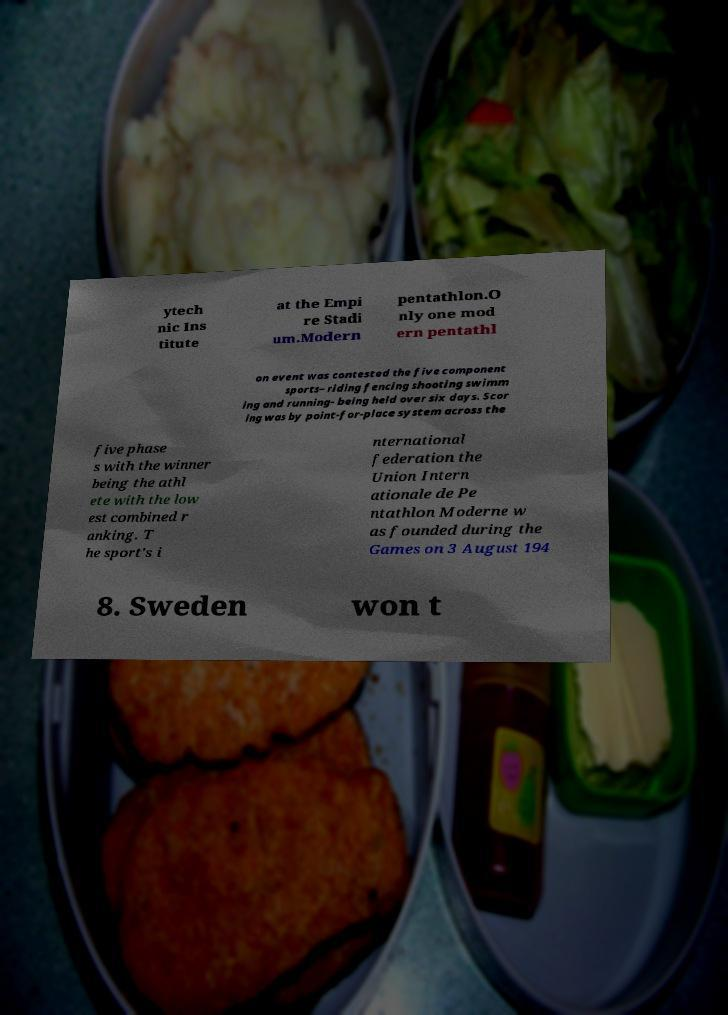Can you read and provide the text displayed in the image?This photo seems to have some interesting text. Can you extract and type it out for me? ytech nic Ins titute at the Empi re Stadi um.Modern pentathlon.O nly one mod ern pentathl on event was contested the five component sports– riding fencing shooting swimm ing and running- being held over six days. Scor ing was by point-for-place system across the five phase s with the winner being the athl ete with the low est combined r anking. T he sport's i nternational federation the Union Intern ationale de Pe ntathlon Moderne w as founded during the Games on 3 August 194 8. Sweden won t 